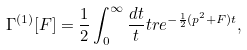<formula> <loc_0><loc_0><loc_500><loc_500>\Gamma ^ { ( 1 ) } [ F ] = \frac { 1 } { 2 } \int _ { 0 } ^ { \infty } \frac { d t } { t } t r e ^ { - \frac { 1 } { 2 } ( p ^ { 2 } + F ) t } ,</formula> 